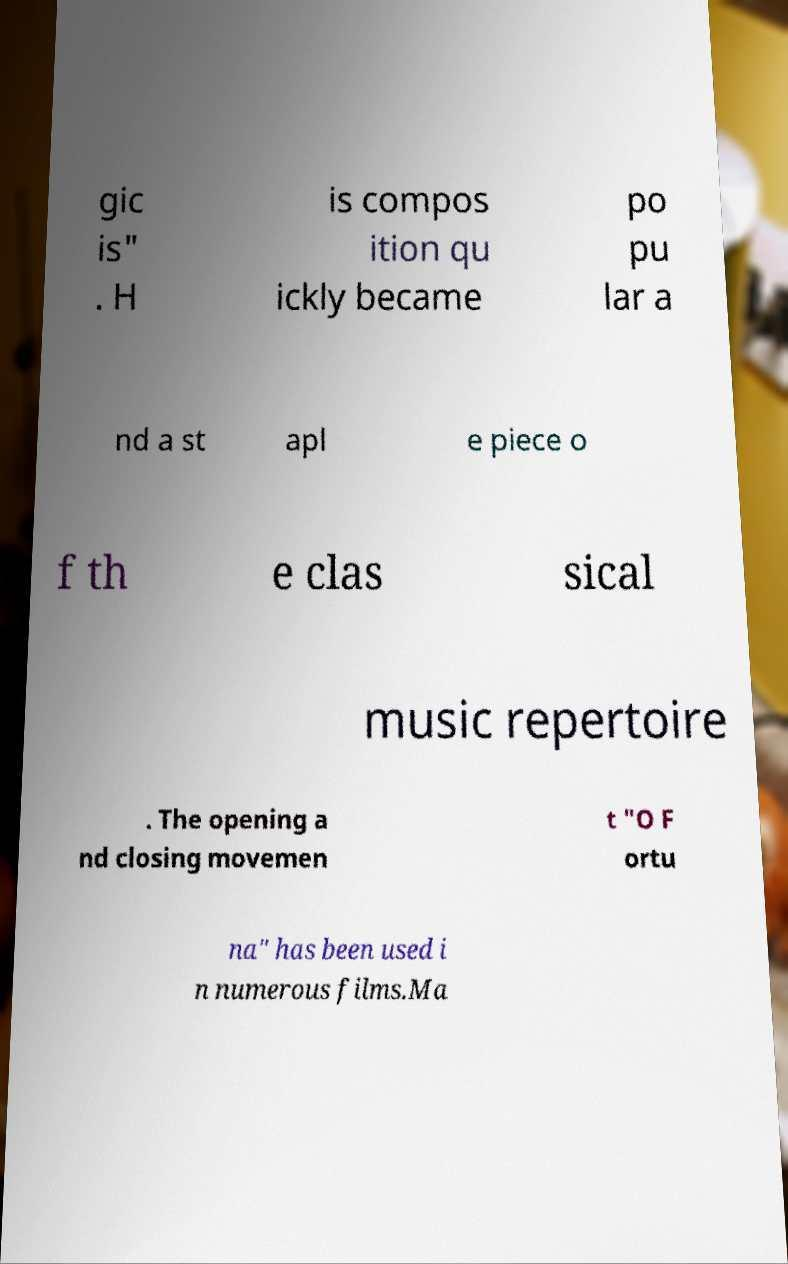I need the written content from this picture converted into text. Can you do that? gic is" . H is compos ition qu ickly became po pu lar a nd a st apl e piece o f th e clas sical music repertoire . The opening a nd closing movemen t "O F ortu na" has been used i n numerous films.Ma 